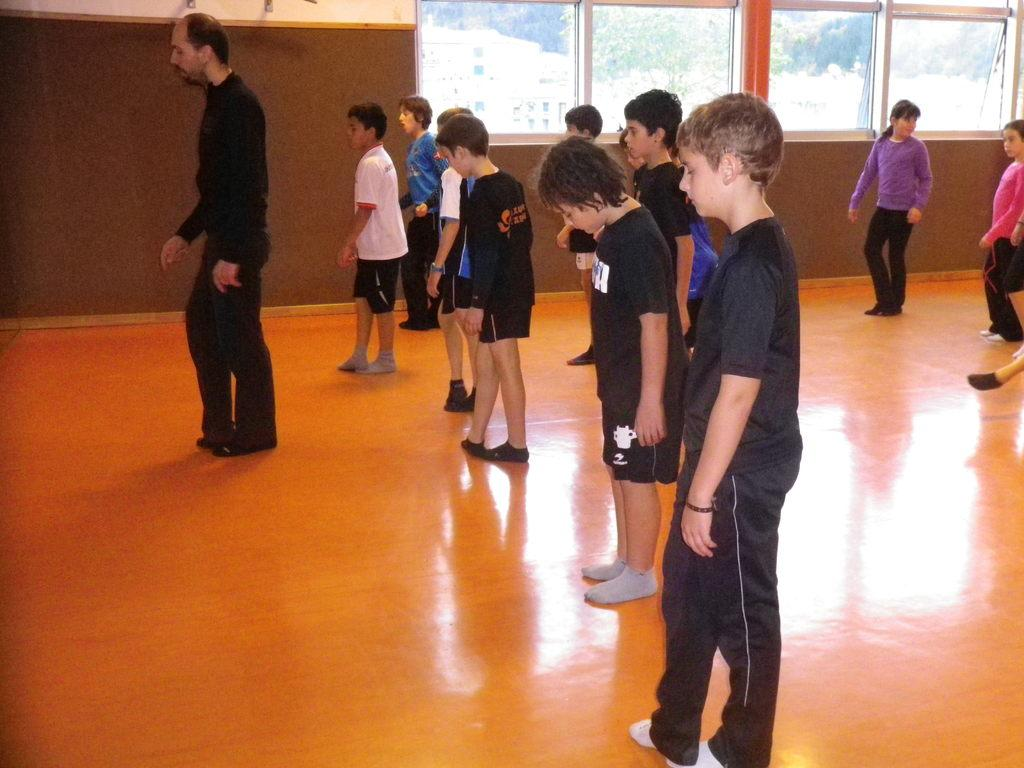What is happening with the people in the image? The people are standing on the floor in the image. What can be seen behind the people? There is a wall in the background of the image. What type of windows are present in the image? There are glass windows in the image. What can be seen through the glass windows? Trees and buildings are visible through the glass windows. What type of board is being used by the people in the image? There is no board present in the image; the people are simply standing on the floor. 